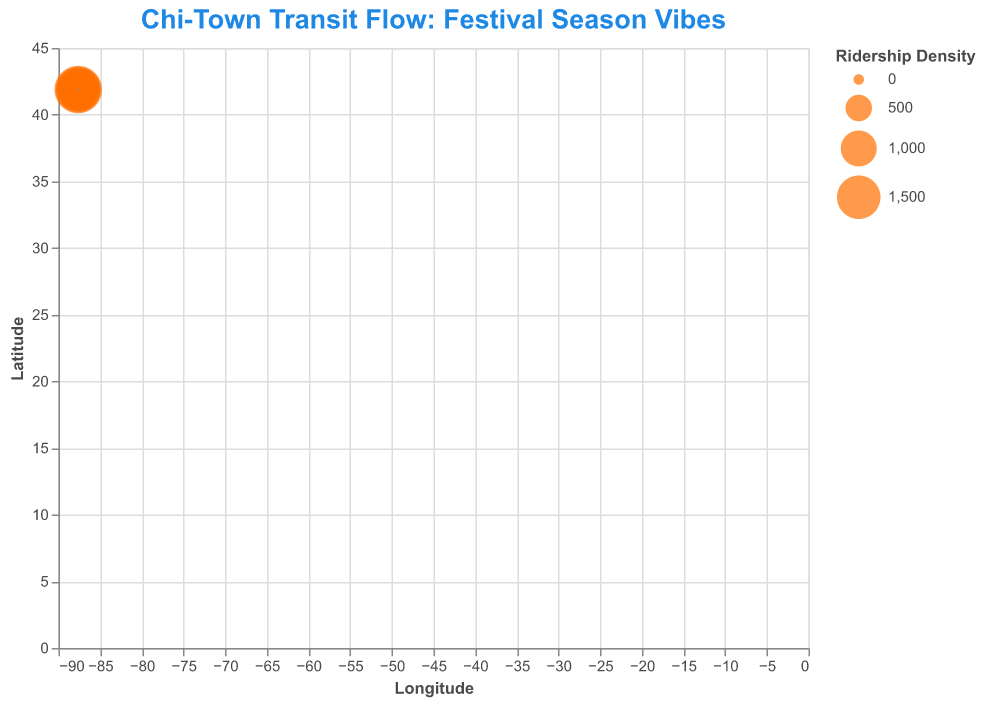What's the title of the plot? The title is located at the top of the figure and is usually the most prominent text element for easy identification. The title sets the context for the figure.
Answer: Chi-Town Transit Flow: Festival Season Vibes What are the variables on the x and y axes? The axis labels for x and y axes provide information on what each axis represents. These labels are placed next to the tick marks.
Answer: Longitude, Latitude Which data point has the highest ridership density? By observing the size of the points on the plot, the largest point corresponds to the data point with the highest ridership density, which is indicated by the size scale in the legend.
Answer: (41.8834, -87.6317) What does the color of the points represent? The description of the mark type includes color information. In this case, all points are one color, which indicates they don't differentiate categories by color. The title suggests a focus on transit and festival vibes, presenting a unified visualization.
Answer: No categories by color; all points are orange At which intersection does the public transportation flow northward the most? To determine this, we need to look for the arrow (quiver) pointing most steeply upward (increasing latitude direction). The steeper the arrow pointing upwards, the stronger the northward flow.
Answer: (41.8781, -87.6298) How many data points are represented in the plot? By counting the distinct points or arrows represented in the plot, each corresponds to one data point in the dataset.
Answer: 10 Which data point has the largest flow magnitude? The point with the largest ridership density size will correspond to the largest magnitude quiver, considering the direction components \(u\) and \(v\).
Answer: (41.8834, -87.6317) Between points (41.8841, -87.6274) and (41.8805, -87.6278), which one has the higher ridership density? By comparing the sizes of the two points corresponding to these coordinates, the one with the larger size has higher ridership density.
Answer: (41.8841, -87.6274) Which area has less than 1000 ridership density but has significant transportation flow? By checking the sizes of points smaller than those representing 1000 on the legend but still showing noticeable direction arrows.
Answer: Areas around (41.8796, -87.6237) and (41.8792, -87.6307) What direction does the flow at (41.8818, -87.6262) point towards the most? Observing the quiver direction from this coordinate by examining the lengths and directions of \(u\) and \(v\). The longer the quiver in one direction, the more dominant that flow direction.
Answer: North-East 